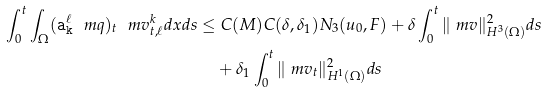<formula> <loc_0><loc_0><loc_500><loc_500>\int _ { 0 } ^ { t } \int _ { \Omega } ( { \tt a _ { k } ^ { \ell } } \ m q ) _ { t } \ m v ^ { k } _ { t , \ell } d x d s \leq & \ C ( M ) C ( \delta , \delta _ { 1 } ) N _ { 3 } ( u _ { 0 } , F ) + \delta \int _ { 0 } ^ { t } \| \ m v \| ^ { 2 } _ { H ^ { 3 } ( \Omega ) } d s \\ & + \delta _ { 1 } \int _ { 0 } ^ { t } \| \ m v _ { t } \| ^ { 2 } _ { H ^ { 1 } ( \Omega ) } d s</formula> 